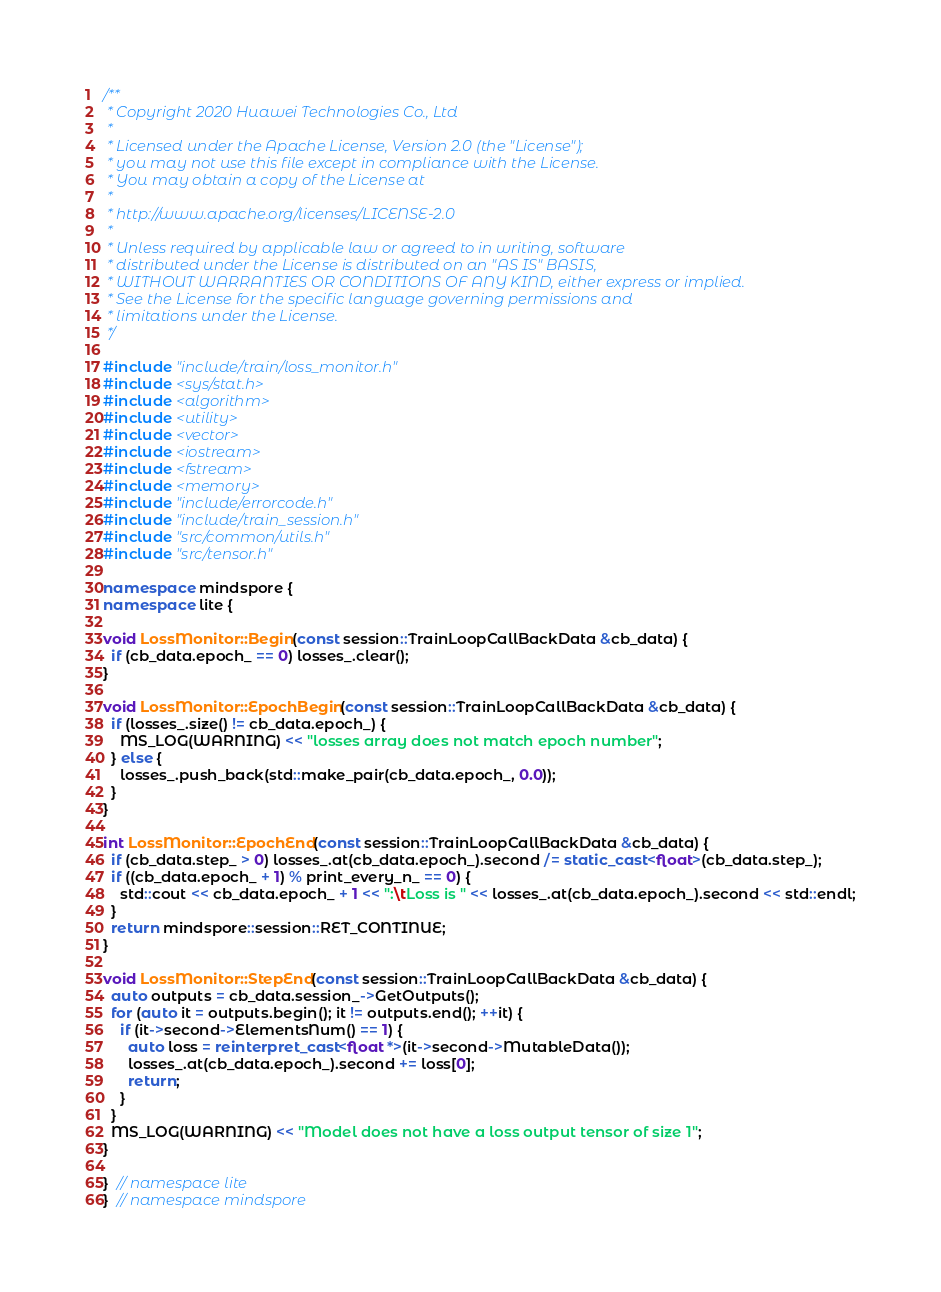Convert code to text. <code><loc_0><loc_0><loc_500><loc_500><_C++_>/**
 * Copyright 2020 Huawei Technologies Co., Ltd
 *
 * Licensed under the Apache License, Version 2.0 (the "License");
 * you may not use this file except in compliance with the License.
 * You may obtain a copy of the License at
 *
 * http://www.apache.org/licenses/LICENSE-2.0
 *
 * Unless required by applicable law or agreed to in writing, software
 * distributed under the License is distributed on an "AS IS" BASIS,
 * WITHOUT WARRANTIES OR CONDITIONS OF ANY KIND, either express or implied.
 * See the License for the specific language governing permissions and
 * limitations under the License.
 */

#include "include/train/loss_monitor.h"
#include <sys/stat.h>
#include <algorithm>
#include <utility>
#include <vector>
#include <iostream>
#include <fstream>
#include <memory>
#include "include/errorcode.h"
#include "include/train_session.h"
#include "src/common/utils.h"
#include "src/tensor.h"

namespace mindspore {
namespace lite {

void LossMonitor::Begin(const session::TrainLoopCallBackData &cb_data) {
  if (cb_data.epoch_ == 0) losses_.clear();
}

void LossMonitor::EpochBegin(const session::TrainLoopCallBackData &cb_data) {
  if (losses_.size() != cb_data.epoch_) {
    MS_LOG(WARNING) << "losses array does not match epoch number";
  } else {
    losses_.push_back(std::make_pair(cb_data.epoch_, 0.0));
  }
}

int LossMonitor::EpochEnd(const session::TrainLoopCallBackData &cb_data) {
  if (cb_data.step_ > 0) losses_.at(cb_data.epoch_).second /= static_cast<float>(cb_data.step_);
  if ((cb_data.epoch_ + 1) % print_every_n_ == 0) {
    std::cout << cb_data.epoch_ + 1 << ":\tLoss is " << losses_.at(cb_data.epoch_).second << std::endl;
  }
  return mindspore::session::RET_CONTINUE;
}

void LossMonitor::StepEnd(const session::TrainLoopCallBackData &cb_data) {
  auto outputs = cb_data.session_->GetOutputs();
  for (auto it = outputs.begin(); it != outputs.end(); ++it) {
    if (it->second->ElementsNum() == 1) {
      auto loss = reinterpret_cast<float *>(it->second->MutableData());
      losses_.at(cb_data.epoch_).second += loss[0];
      return;
    }
  }
  MS_LOG(WARNING) << "Model does not have a loss output tensor of size 1";
}

}  // namespace lite
}  // namespace mindspore
</code> 